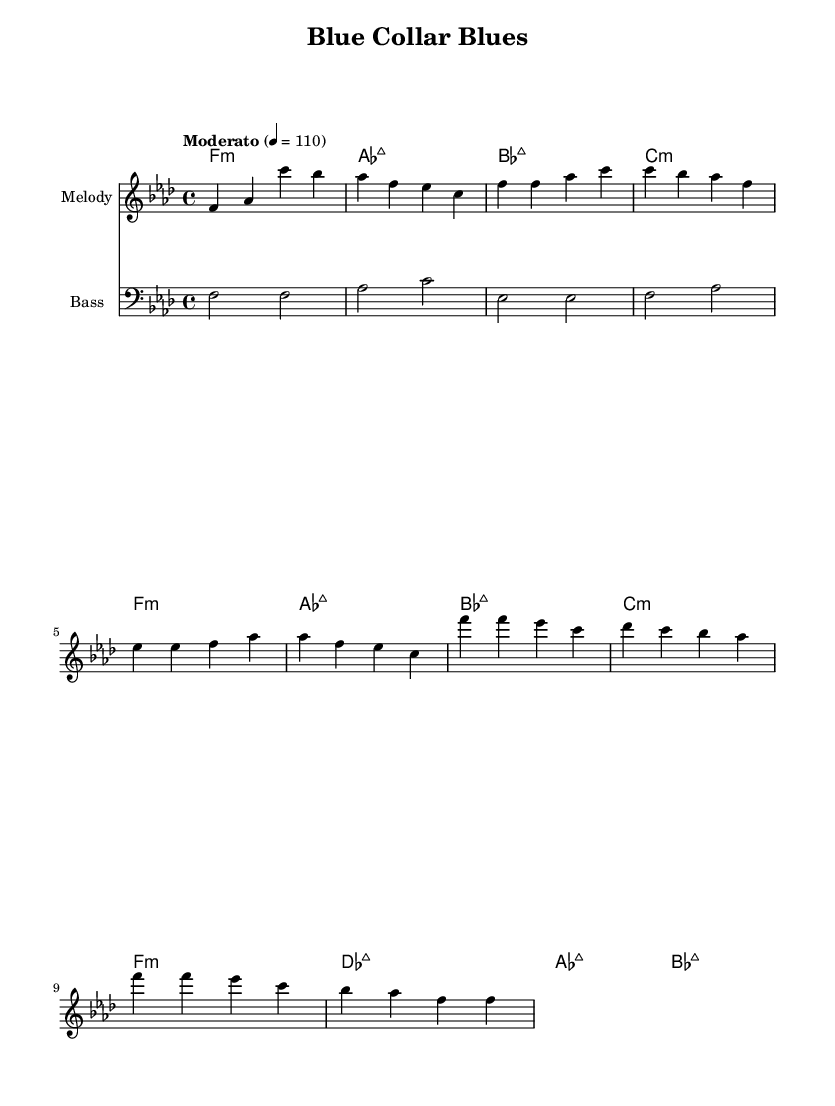What is the key signature of this music? The key signature is F minor, which has four flats (B♭, E♭, A♭, and D♭). This is indicated at the beginning of the music.
Answer: F minor What is the time signature of this music? The time signature is 4/4, meaning there are four beats in a measure, and the quarter note gets one beat. This can be identified at the beginning of the score next to the key signature.
Answer: 4/4 What is the tempo marking of this music? The tempo marking is "Moderato," which implies a moderate speed. This is indicated at the top of the score under the tempo instruction, which also specifies a metronome marking of 110 beats per minute.
Answer: Moderato What is the primary mood or theme conveyed by the title "Blue Collar Blues"? The title suggests a theme related to the struggles or experiences of blue-collar workers, which aligns with socially conscious funk music that often addresses working-class issues. This can be inferred from the title alone.
Answer: Struggles How many measures are in the intro section? The intro section consists of four measures, which can be counted by looking at the melody line and noting where each measure ends based on the bar lines.
Answer: 4 How does the harmony support the melody in the chorus? The harmony in the chorus includes a shift to des major, which creates a contrast in sound that complements the melody and emphasizes the thematic shifts typical in funk music. This requires examining both the melody and the harmonies played underneath.
Answer: Contrast What instrument is indicated for the bass line? The bass line is indicated for the bass instrument, as shown at the beginning of the corresponding staff where it specifically states "Bass." This indicates the part written is intended for a bass instrument.
Answer: Bass 